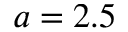Convert formula to latex. <formula><loc_0><loc_0><loc_500><loc_500>a = 2 . 5</formula> 